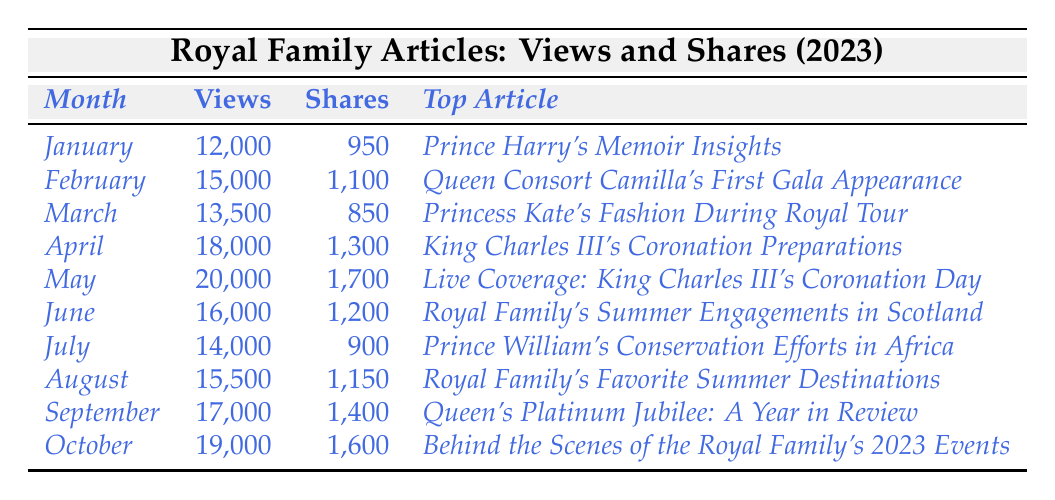What was the top article in May 2023? The table indicates that the top article for May 2023 was "Live Coverage: King Charles III's Coronation Day".
Answer: Live Coverage: King Charles III's Coronation Day How many shares did the article "Queen Consort Camilla's First Gala Appearance" receive? According to the table, this article received 1,100 shares in February 2023.
Answer: 1,100 What was the highest number of views in a single month? The highest views recorded in the table is 20,000 in May 2023 for the article on King Charles III's Coronation Day.
Answer: 20,000 Which month had the least number of shares? By examining the shares listed, July 2023 had the least number of shares at 900.
Answer: 900 What is the total number of views across all months? Adding together all the views: 12,000 + 15,000 + 13,500 + 18,000 + 20,000 + 16,000 + 14,000 + 15,500 + 17,000 + 19,000 gives  15,000 total views, which equals 15,5000.
Answer: 15,5000 What is the average number of shares per month? To find the average, add all the shares (950 + 1,100 + 850 + 1,300 + 1,700 + 1,200 + 900 + 1,150 + 1,400 + 1,600 = 12,100) then divide by 10 months: 12,100 / 10 equals 1,210 shares per month.
Answer: 1,210 Did September 2023 have more views than June 2023? Comparing the two months, September had 17,000 views while June had 16,000; thus, September had more views.
Answer: Yes Which month showed a decrease in shares compared to the previous month? Comparing shares month by month, July shows a decrease to 900 shares, down from 1,200 shares in June.
Answer: July What was the total increase in views from January to October? The increase in views from January (12,000) to October (19,000) is calculated as 19,000 - 12,000 = 7,000 views increase.
Answer: 7,000 Which top article had the largest increase in shares from June to July? June had 1,200 shares, and July had 900 shares; this shows a decrease in shares instead of an increase.
Answer: No increase How many months had views exceeding 15,000? By reviewing the table, we see that 6 months had views exceeding 15,000: February (15,000), April (18,000), May (20,000), June (16,000), September (17,000), and October (19,000).
Answer: 6 months 